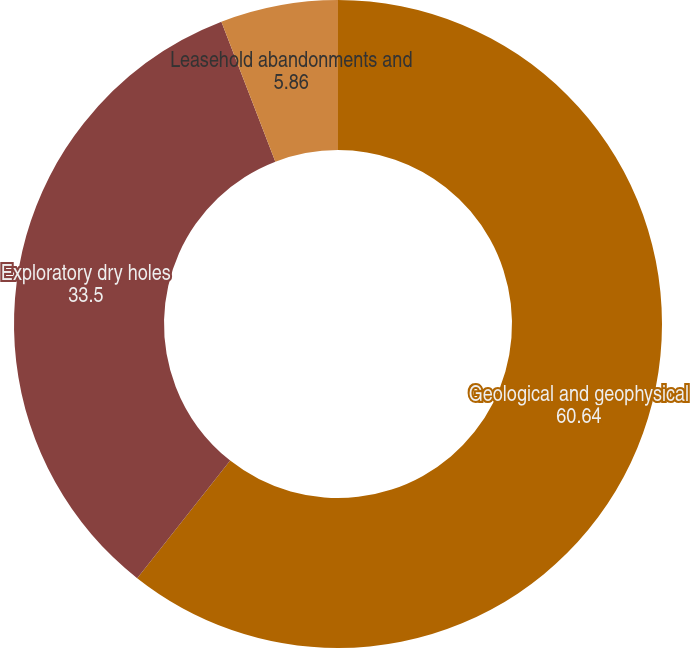Convert chart. <chart><loc_0><loc_0><loc_500><loc_500><pie_chart><fcel>Geological and geophysical<fcel>Exploratory dry holes<fcel>Leasehold abandonments and<nl><fcel>60.64%<fcel>33.5%<fcel>5.86%<nl></chart> 